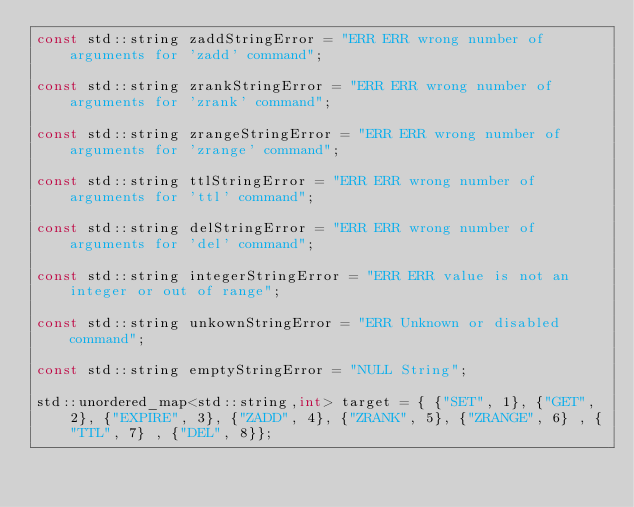Convert code to text. <code><loc_0><loc_0><loc_500><loc_500><_C++_>const std::string zaddStringError = "ERR ERR wrong number of arguments for 'zadd' command";

const std::string zrankStringError = "ERR ERR wrong number of arguments for 'zrank' command";

const std::string zrangeStringError = "ERR ERR wrong number of arguments for 'zrange' command";

const std::string ttlStringError = "ERR ERR wrong number of arguments for 'ttl' command";

const std::string delStringError = "ERR ERR wrong number of arguments for 'del' command";

const std::string integerStringError = "ERR ERR value is not an integer or out of range";

const std::string unkownStringError = "ERR Unknown or disabled command";

const std::string emptyStringError = "NULL String";
 
std::unordered_map<std::string,int> target = { {"SET", 1}, {"GET", 2}, {"EXPIRE", 3}, {"ZADD", 4}, {"ZRANK", 5}, {"ZRANGE", 6} , {"TTL", 7} , {"DEL", 8}};
    
    
    
    

</code> 